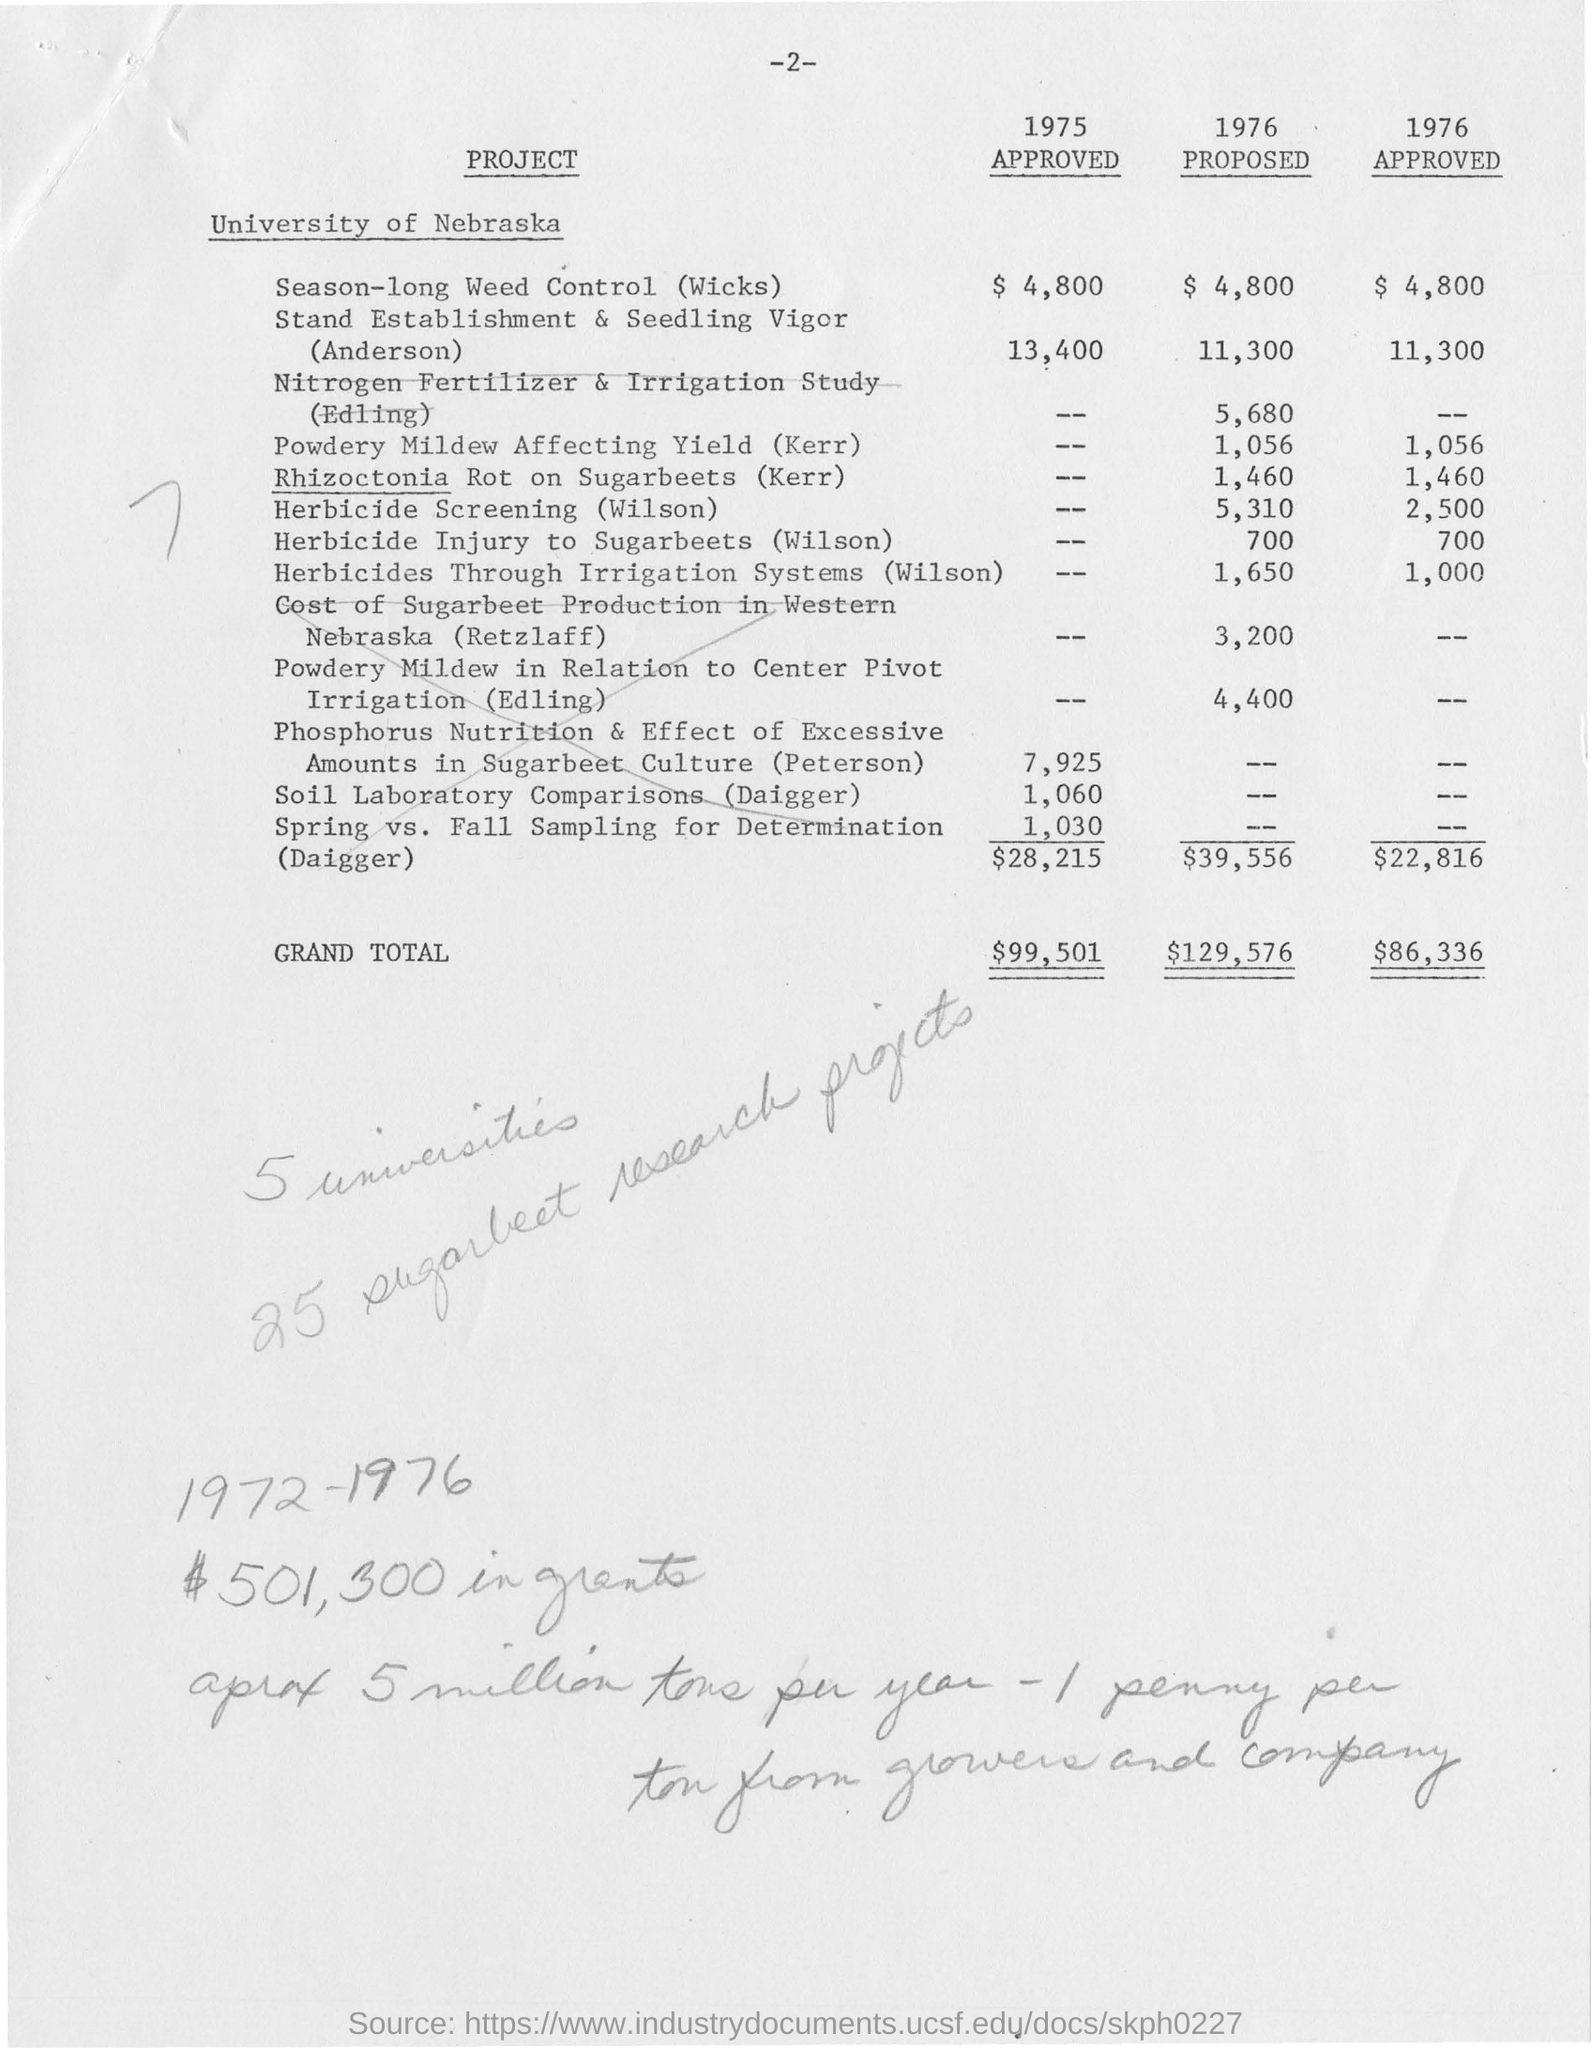Highlight a few significant elements in this photo. The approved grand total amount for the year 1976 was $86,336. The approved amount for season-long weed control, also known as wicks, in the year 1975 was $4,800. The University of Nebraska is the name of the university mentioned. The grand total amount for the year 1975 was $99,501. The proposed grand total amount for the year 1976 is $129,576. 